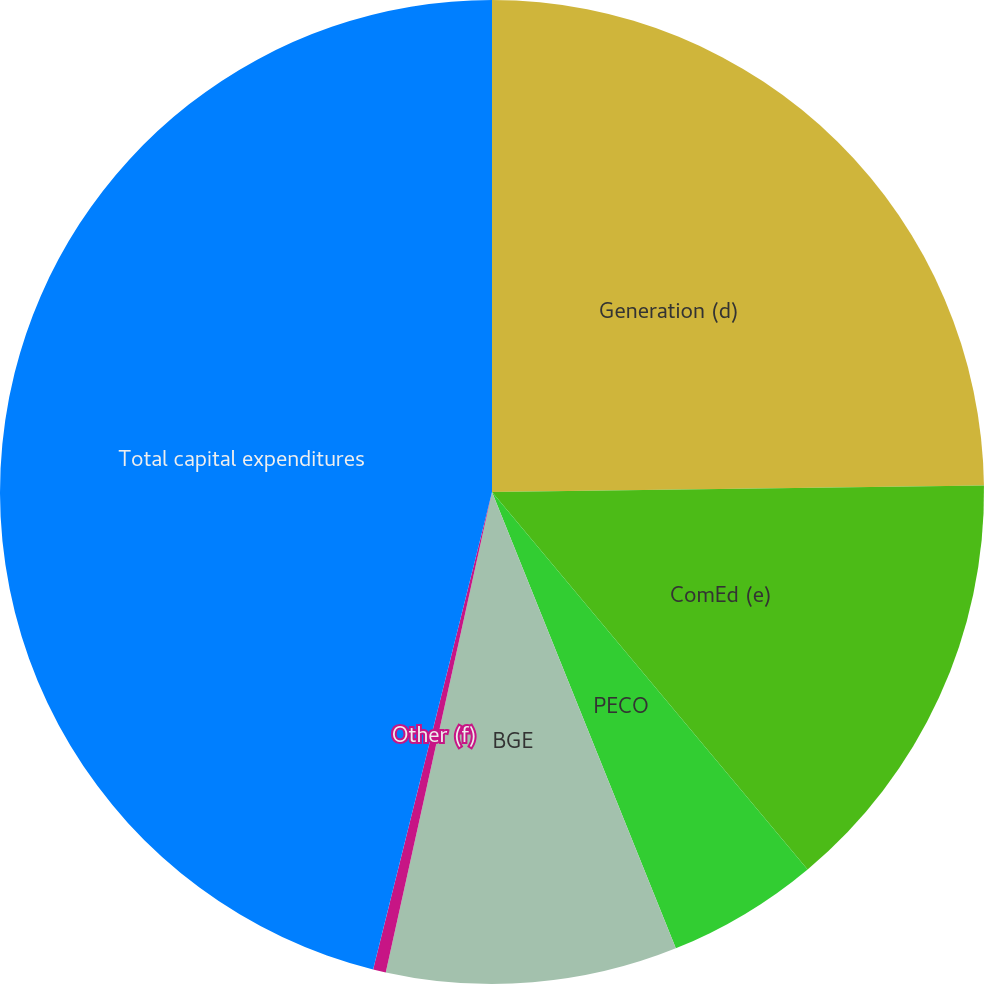Convert chart. <chart><loc_0><loc_0><loc_500><loc_500><pie_chart><fcel>Generation (d)<fcel>ComEd (e)<fcel>PECO<fcel>BGE<fcel>Other (f)<fcel>Total capital expenditures<nl><fcel>24.79%<fcel>14.13%<fcel>4.99%<fcel>9.56%<fcel>0.42%<fcel>46.12%<nl></chart> 